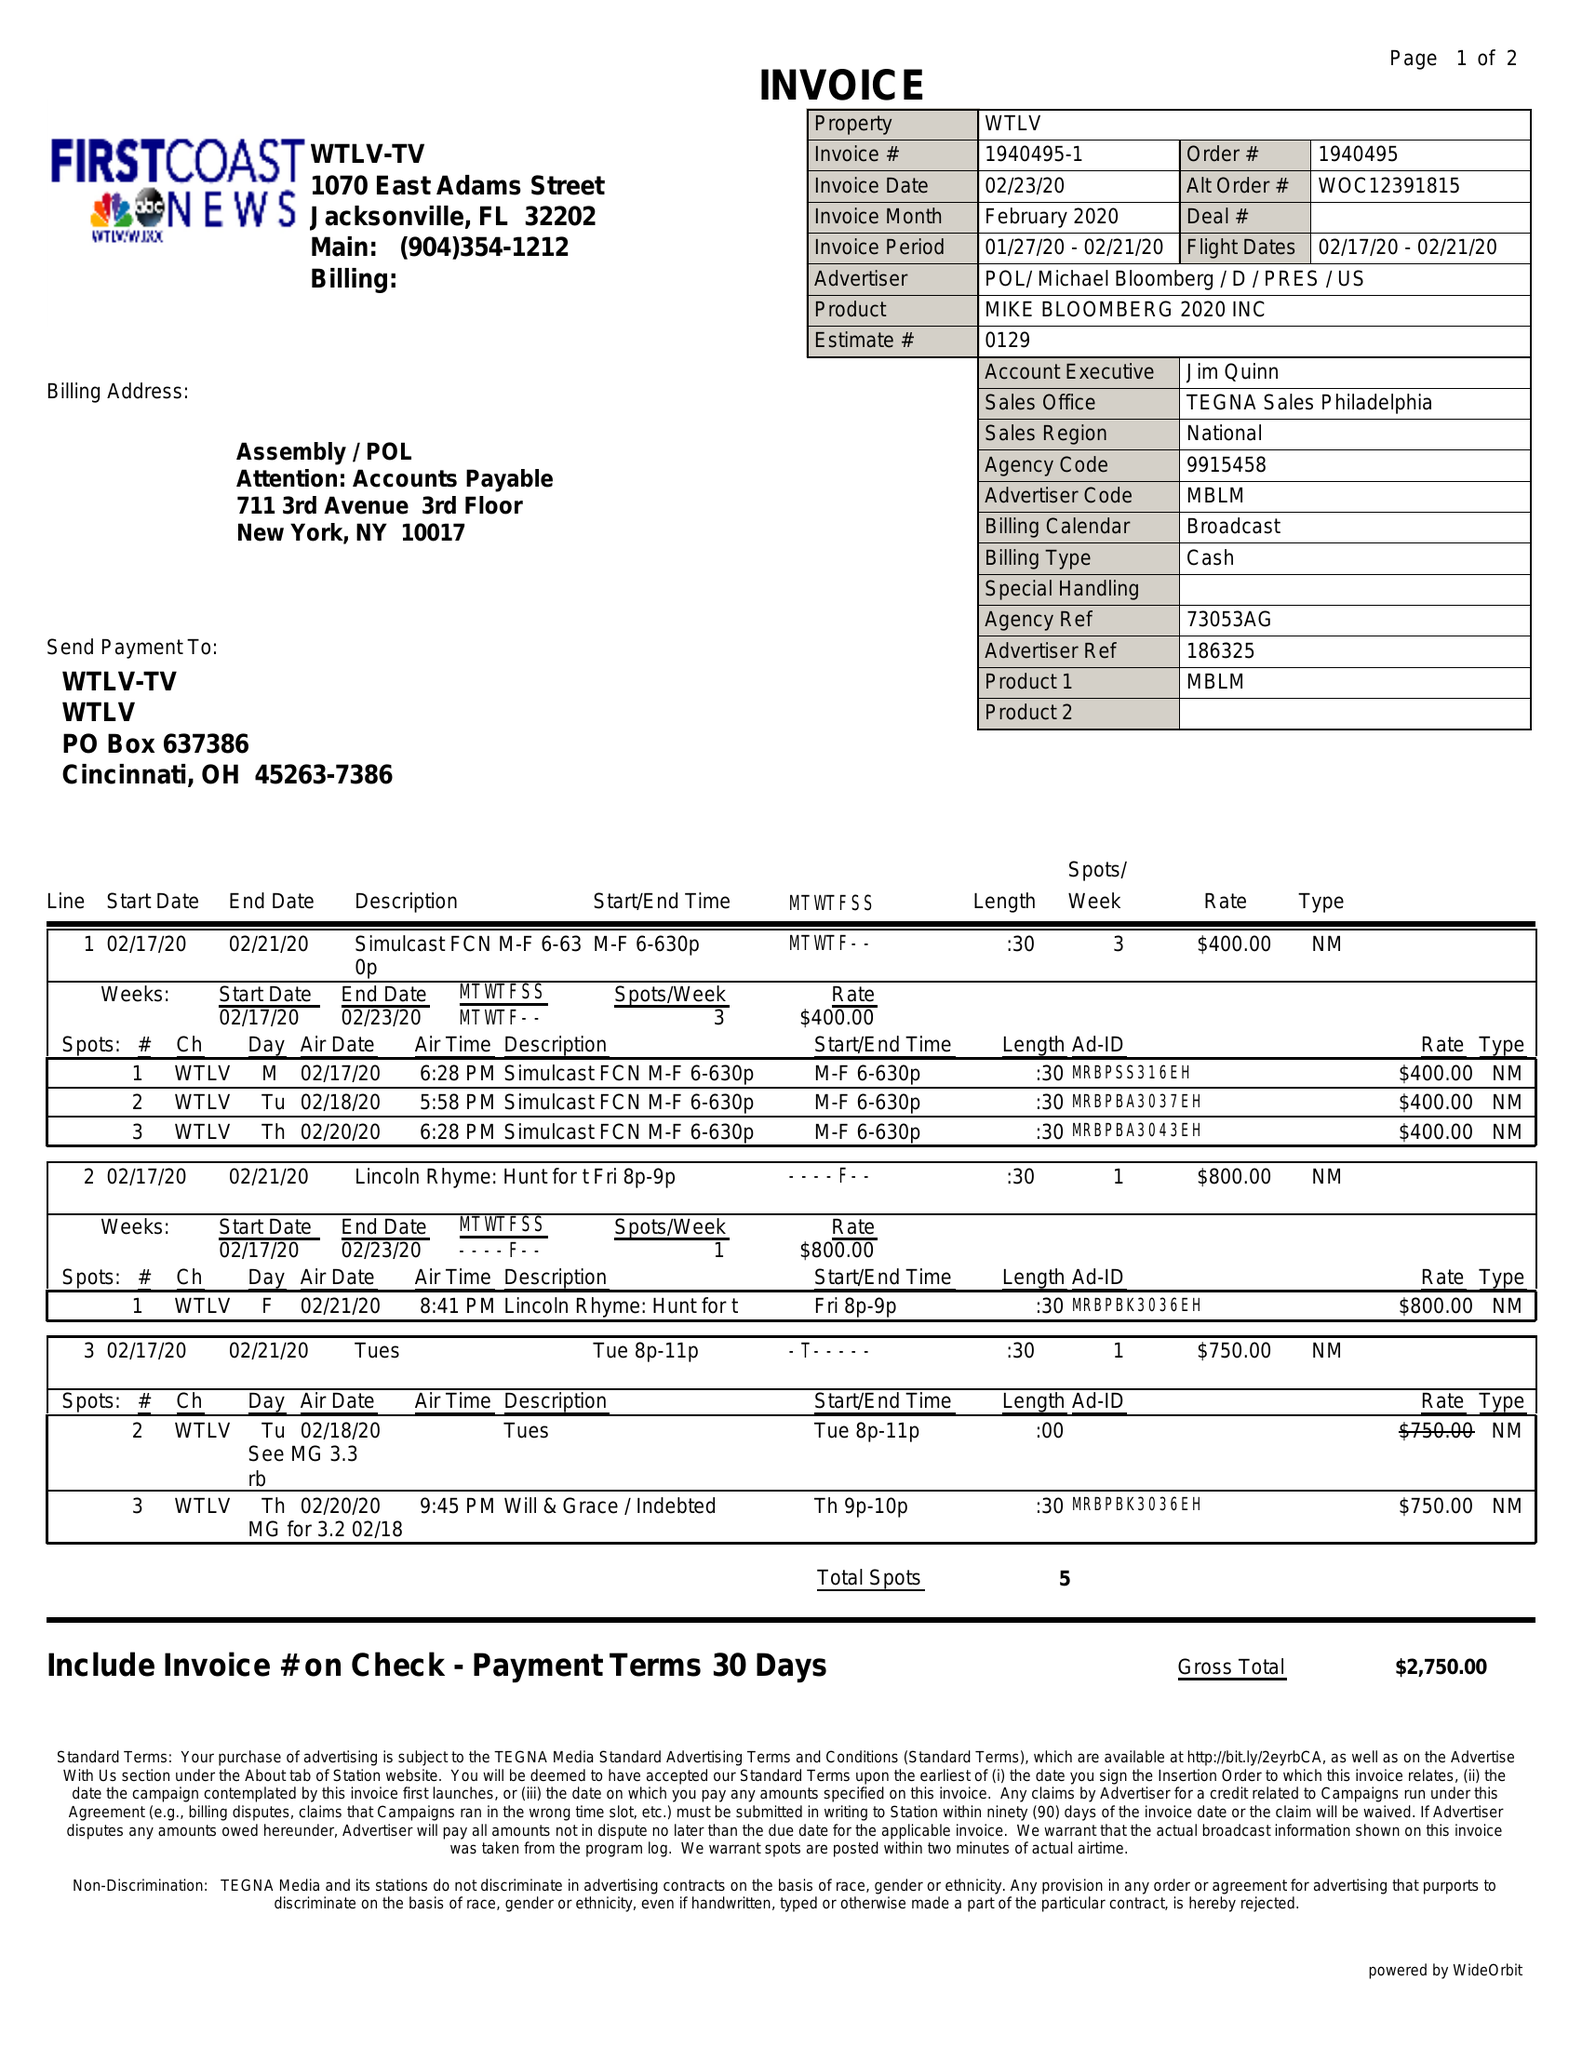What is the value for the contract_num?
Answer the question using a single word or phrase. 1940495 